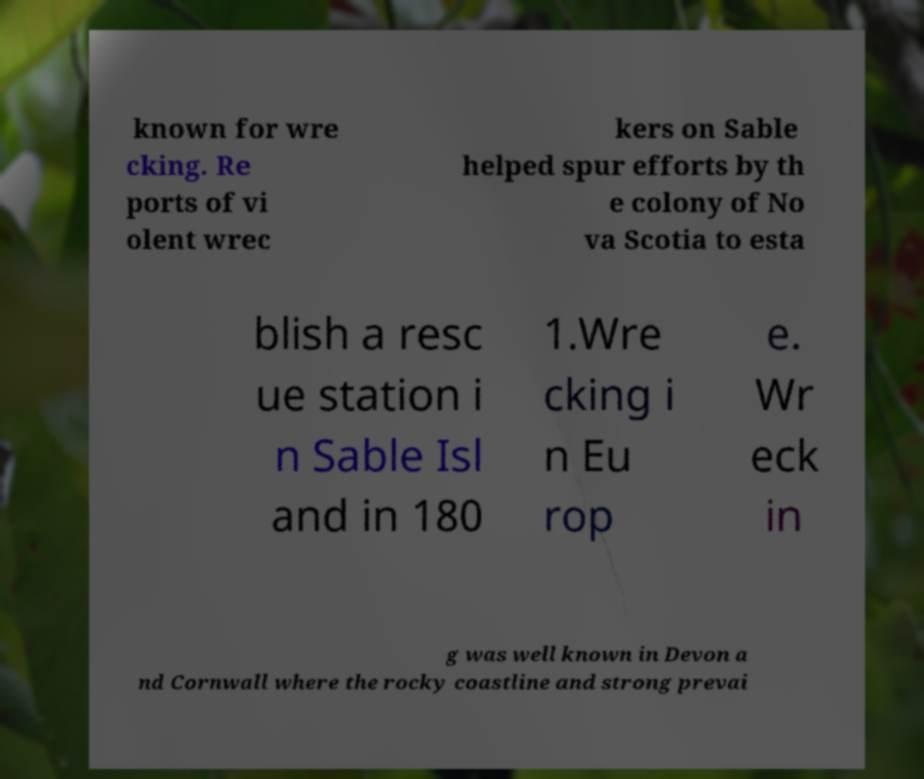Could you extract and type out the text from this image? known for wre cking. Re ports of vi olent wrec kers on Sable helped spur efforts by th e colony of No va Scotia to esta blish a resc ue station i n Sable Isl and in 180 1.Wre cking i n Eu rop e. Wr eck in g was well known in Devon a nd Cornwall where the rocky coastline and strong prevai 